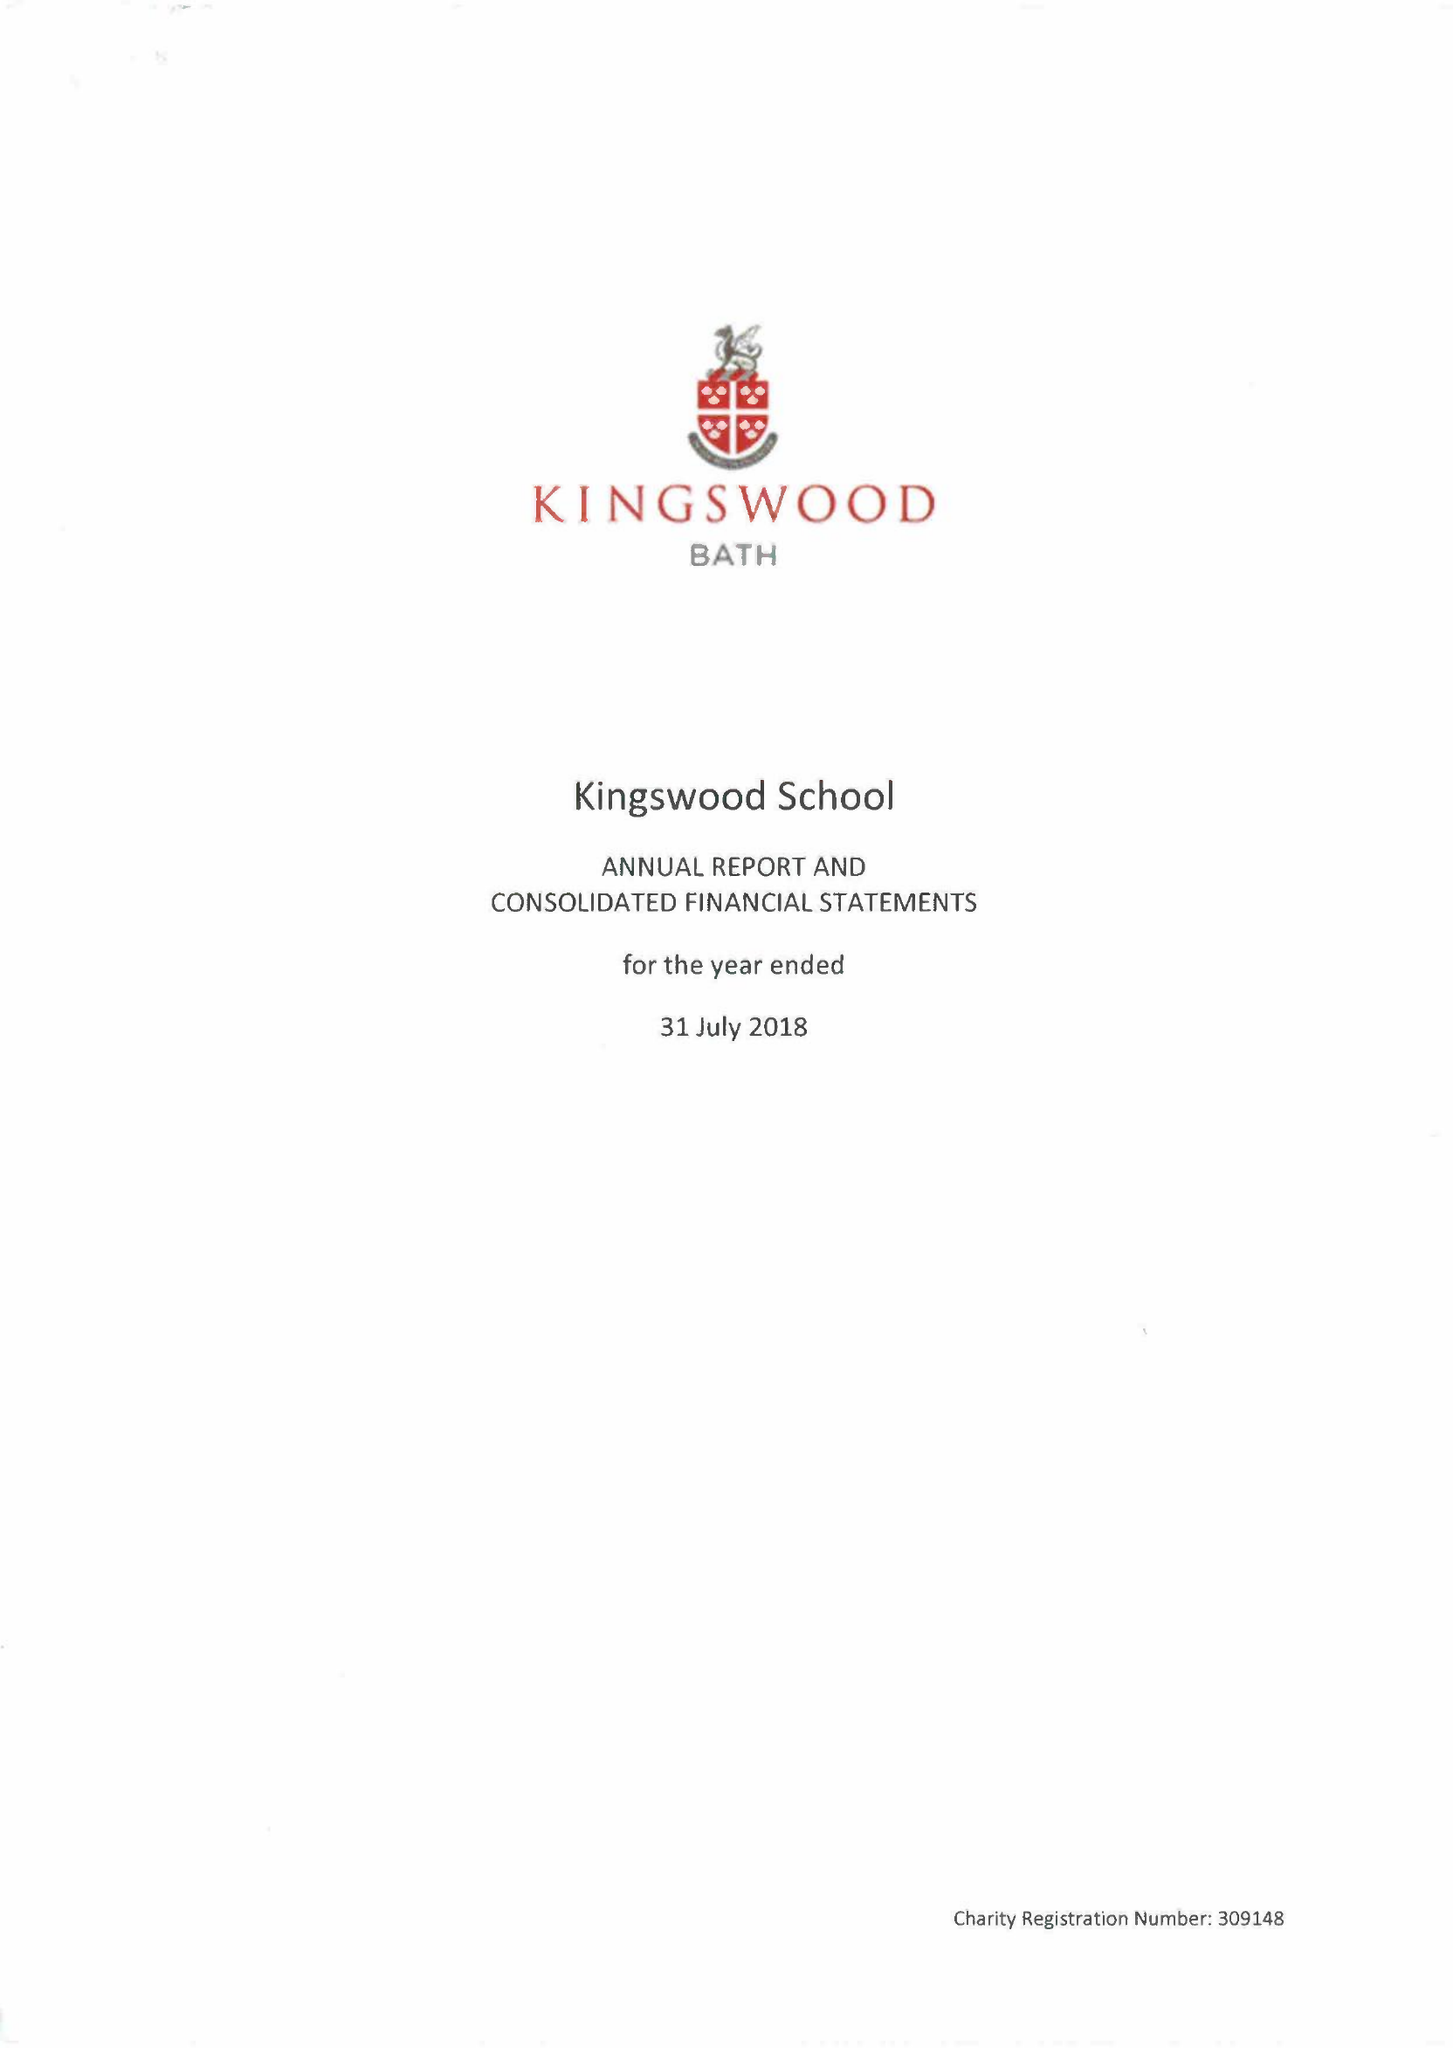What is the value for the spending_annually_in_british_pounds?
Answer the question using a single word or phrase. 18302045.00 